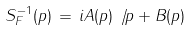Convert formula to latex. <formula><loc_0><loc_0><loc_500><loc_500>S _ { F } ^ { - 1 } ( p ) \, = \, i A ( p ) \not \, p + B ( p )</formula> 